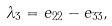Convert formula to latex. <formula><loc_0><loc_0><loc_500><loc_500>\lambda _ { 3 } = e _ { 2 2 } - e _ { 3 3 } ,</formula> 